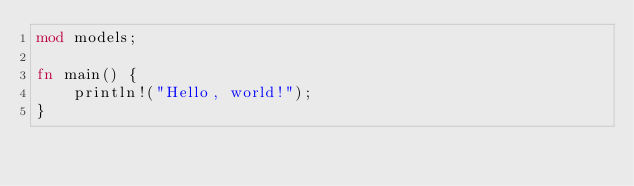Convert code to text. <code><loc_0><loc_0><loc_500><loc_500><_Rust_>mod models;

fn main() {
    println!("Hello, world!");
}
</code> 